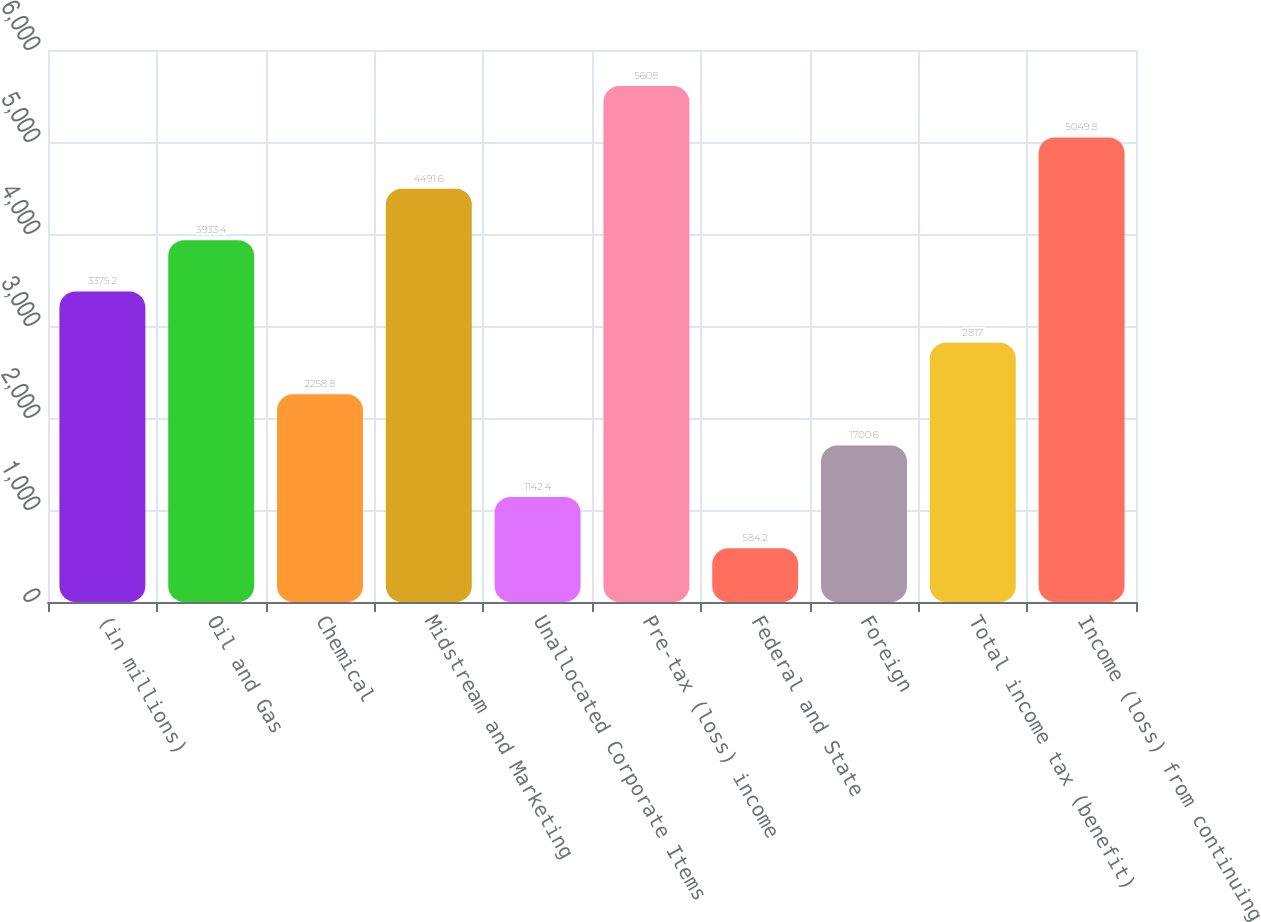Convert chart. <chart><loc_0><loc_0><loc_500><loc_500><bar_chart><fcel>(in millions)<fcel>Oil and Gas<fcel>Chemical<fcel>Midstream and Marketing<fcel>Unallocated Corporate Items<fcel>Pre-tax (loss) income<fcel>Federal and State<fcel>Foreign<fcel>Total income tax (benefit)<fcel>Income (loss) from continuing<nl><fcel>3375.2<fcel>3933.4<fcel>2258.8<fcel>4491.6<fcel>1142.4<fcel>5608<fcel>584.2<fcel>1700.6<fcel>2817<fcel>5049.8<nl></chart> 